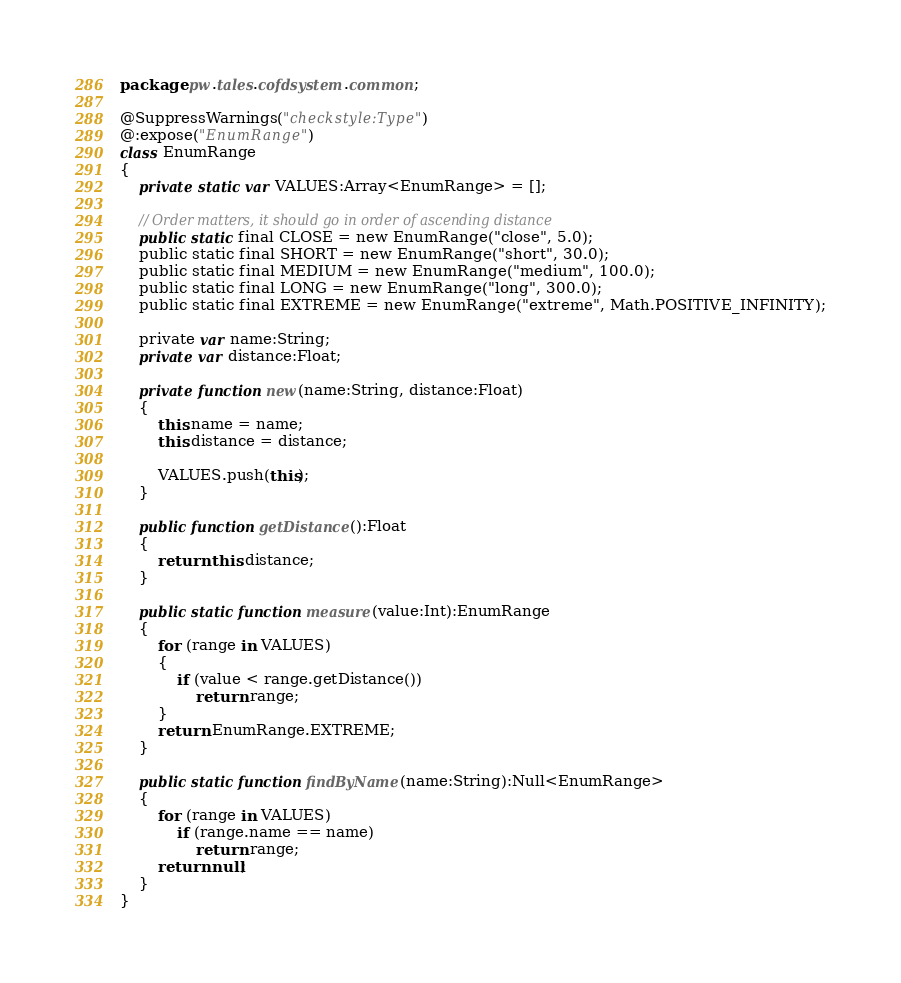Convert code to text. <code><loc_0><loc_0><loc_500><loc_500><_Haxe_>package pw.tales.cofdsystem.common;

@SuppressWarnings("checkstyle:Type")
@:expose("EnumRange")
class EnumRange
{
    private static var VALUES:Array<EnumRange> = [];

    // Order matters, it should go in order of ascending distance
    public static final CLOSE = new EnumRange("close", 5.0);
    public static final SHORT = new EnumRange("short", 30.0);
    public static final MEDIUM = new EnumRange("medium", 100.0);
    public static final LONG = new EnumRange("long", 300.0);
    public static final EXTREME = new EnumRange("extreme", Math.POSITIVE_INFINITY);

    private var name:String;
    private var distance:Float;

    private function new(name:String, distance:Float)
    {
        this.name = name;
        this.distance = distance;

        VALUES.push(this);
    }

    public function getDistance():Float
    {
        return this.distance;
    }

    public static function measure(value:Int):EnumRange
    {
        for (range in VALUES)
        {
            if (value < range.getDistance())
                return range;
        }
        return EnumRange.EXTREME;
    }

    public static function findByName(name:String):Null<EnumRange>
    {
        for (range in VALUES)
            if (range.name == name)
                return range;
        return null;
    }
}
</code> 